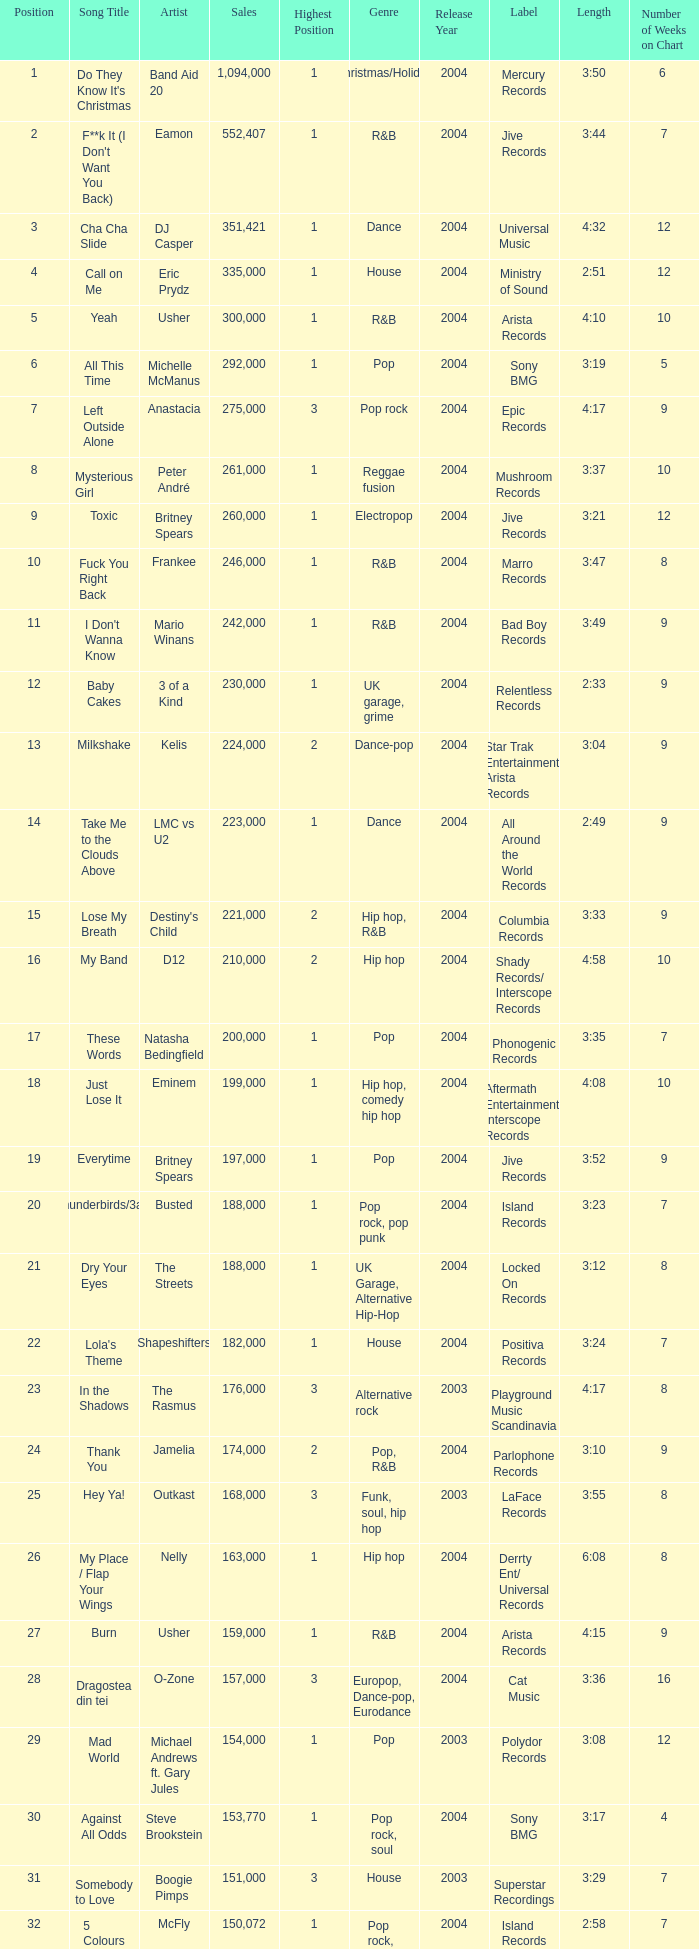What is the most sales by a song with a position higher than 3? None. 